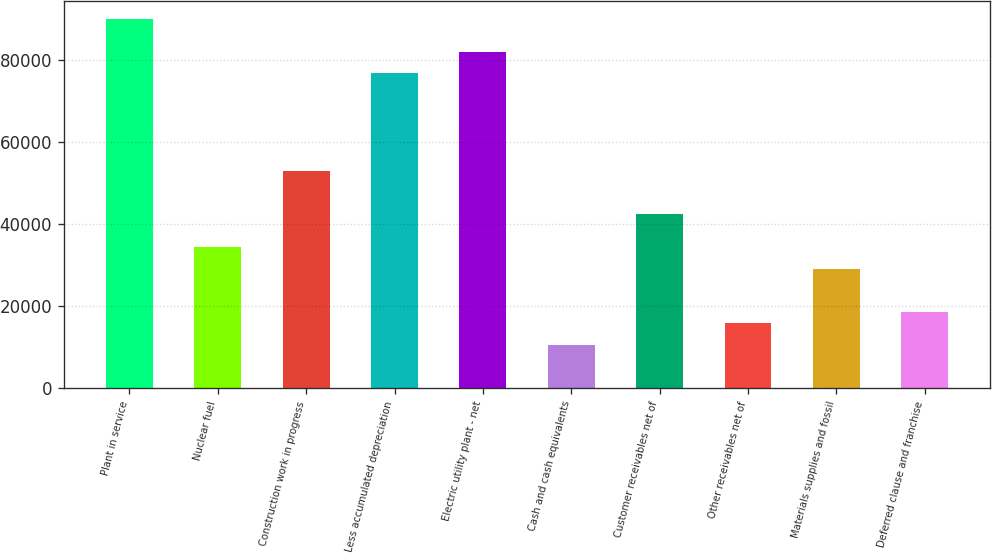Convert chart. <chart><loc_0><loc_0><loc_500><loc_500><bar_chart><fcel>Plant in service<fcel>Nuclear fuel<fcel>Construction work in progress<fcel>Less accumulated depreciation<fcel>Electric utility plant - net<fcel>Cash and cash equivalents<fcel>Customer receivables net of<fcel>Other receivables net of<fcel>Materials supplies and fossil<fcel>Deferred clause and franchise<nl><fcel>90063.4<fcel>34442.8<fcel>52983<fcel>76820.4<fcel>82117.6<fcel>10605.4<fcel>42388.6<fcel>15902.6<fcel>29145.6<fcel>18551.2<nl></chart> 